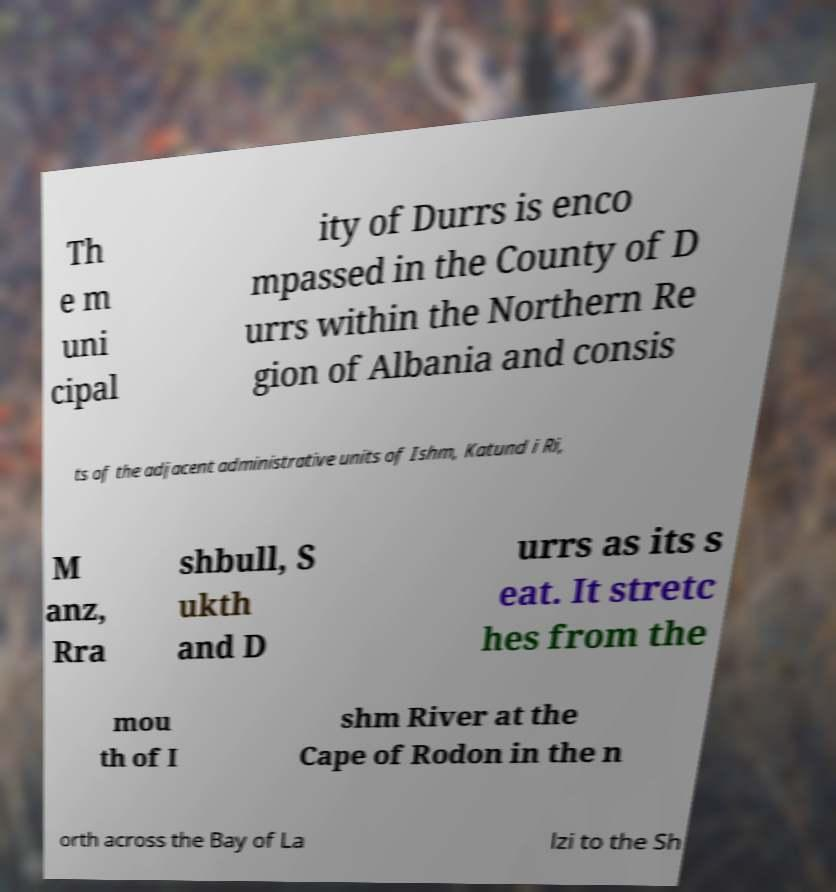There's text embedded in this image that I need extracted. Can you transcribe it verbatim? Th e m uni cipal ity of Durrs is enco mpassed in the County of D urrs within the Northern Re gion of Albania and consis ts of the adjacent administrative units of Ishm, Katund i Ri, M anz, Rra shbull, S ukth and D urrs as its s eat. It stretc hes from the mou th of I shm River at the Cape of Rodon in the n orth across the Bay of La lzi to the Sh 